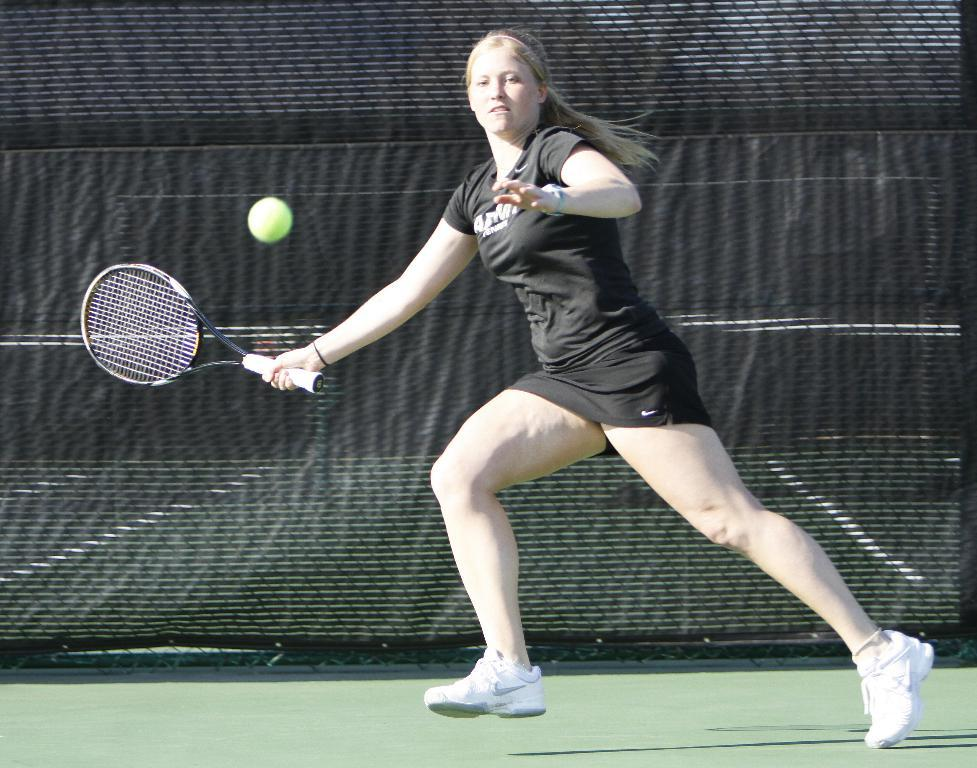What is the main subject of the image? There is a person in the image. What is the person holding in the image? The person is holding a bat. What else can be seen in the image besides the person? There is a net visible in the image. What type of spring can be seen in the image? There is no spring present in the image. 